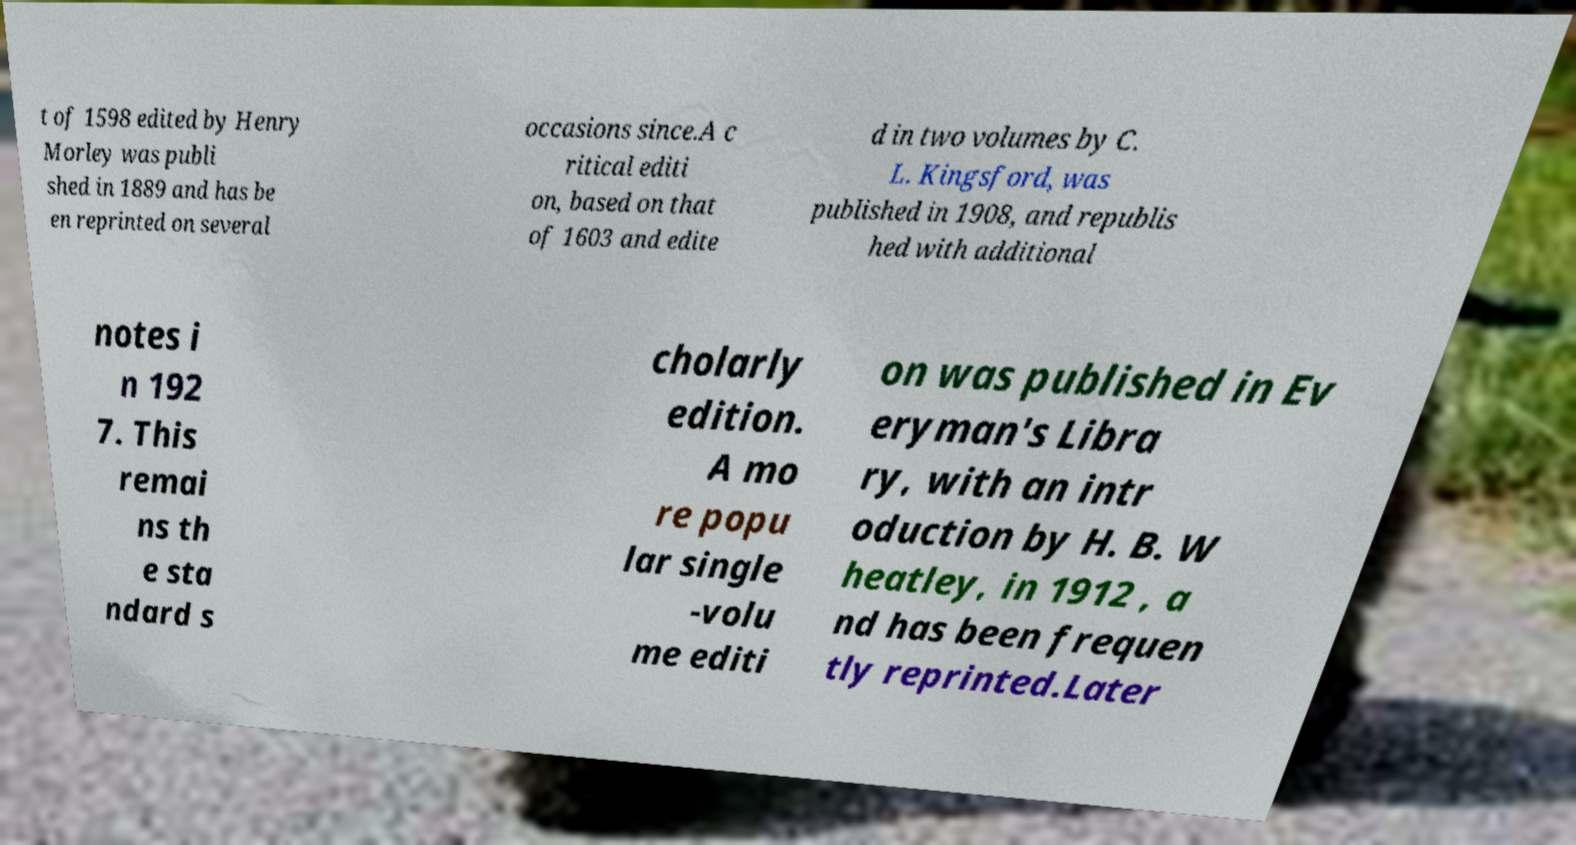Can you accurately transcribe the text from the provided image for me? t of 1598 edited by Henry Morley was publi shed in 1889 and has be en reprinted on several occasions since.A c ritical editi on, based on that of 1603 and edite d in two volumes by C. L. Kingsford, was published in 1908, and republis hed with additional notes i n 192 7. This remai ns th e sta ndard s cholarly edition. A mo re popu lar single -volu me editi on was published in Ev eryman's Libra ry, with an intr oduction by H. B. W heatley, in 1912 , a nd has been frequen tly reprinted.Later 